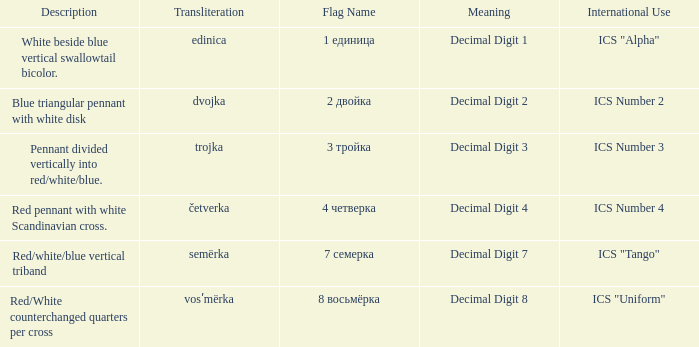Could you parse the entire table as a dict? {'header': ['Description', 'Transliteration', 'Flag Name', 'Meaning', 'International Use'], 'rows': [['White beside blue vertical swallowtail bicolor.', 'edinica', '1 единица', 'Decimal Digit 1', 'ICS "Alpha"'], ['Blue triangular pennant with white disk', 'dvojka', '2 двойка', 'Decimal Digit 2', 'ICS Number 2'], ['Pennant divided vertically into red/white/blue.', 'trojka', '3 тройка', 'Decimal Digit 3', 'ICS Number 3'], ['Red pennant with white Scandinavian cross.', 'četverka', '4 четверка', 'Decimal Digit 4', 'ICS Number 4'], ['Red/white/blue vertical triband', 'semërka', '7 семерка', 'Decimal Digit 7', 'ICS "Tango"'], ['Red/White counterchanged quarters per cross', 'vosʹmërka', '8 восьмёрка', 'Decimal Digit 8', 'ICS "Uniform"']]} What is the international use of the 1 единица flag? ICS "Alpha". 